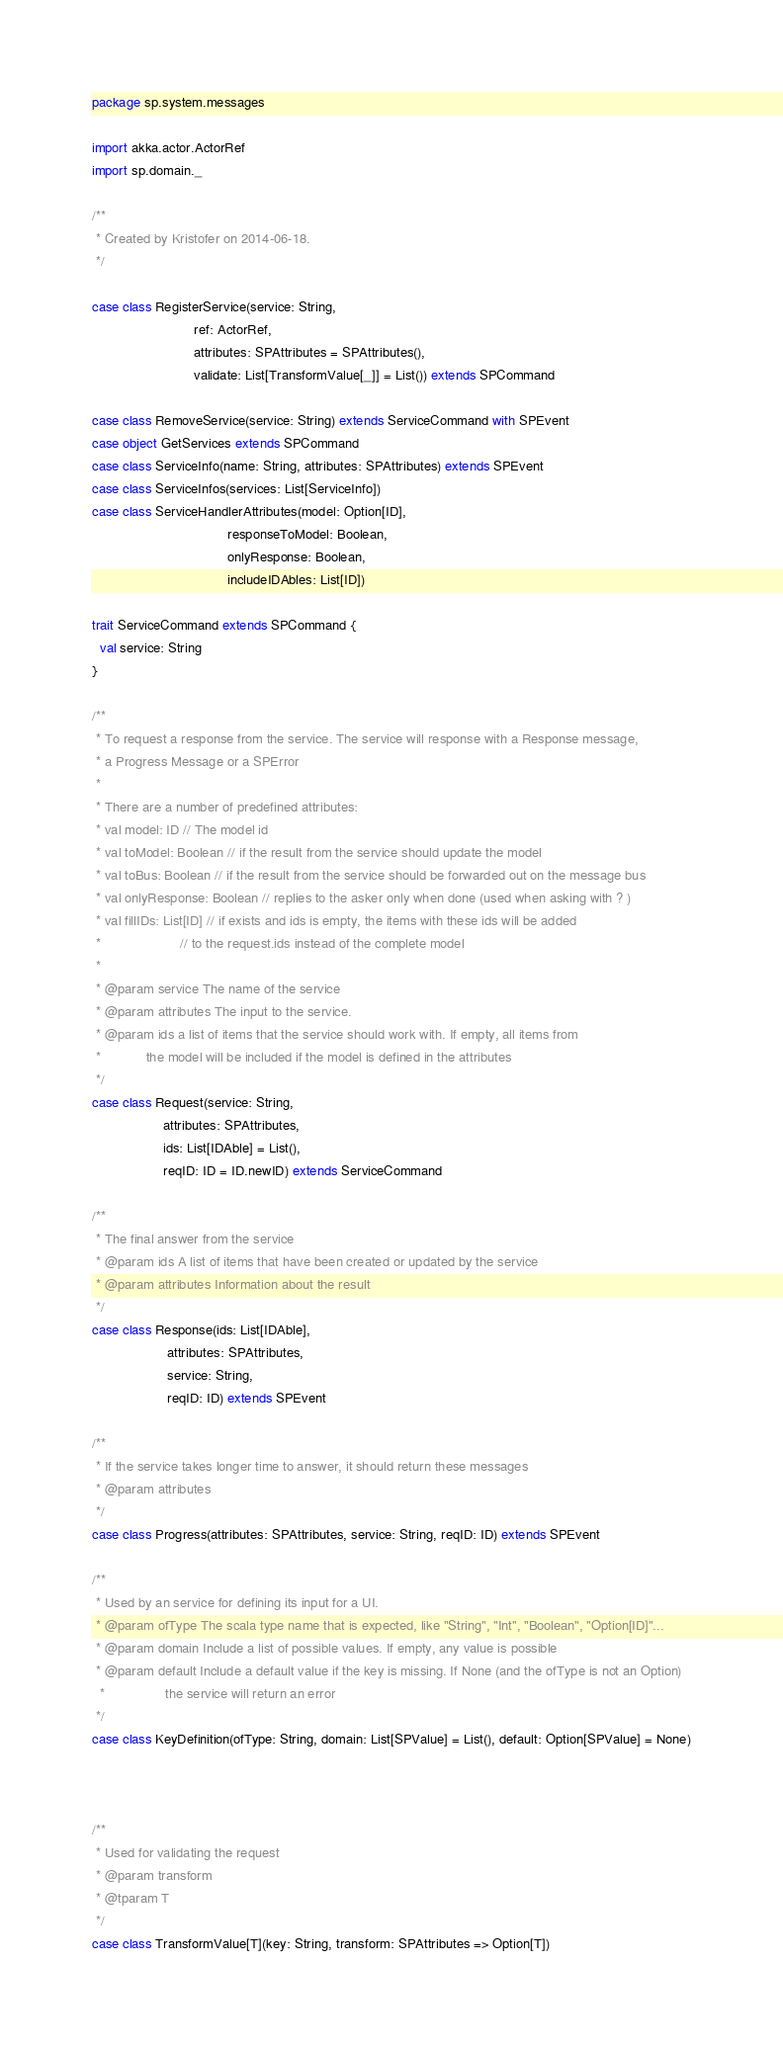<code> <loc_0><loc_0><loc_500><loc_500><_Scala_>package sp.system.messages

import akka.actor.ActorRef
import sp.domain._

/**
 * Created by Kristofer on 2014-06-18.
 */

case class RegisterService(service: String,
                           ref: ActorRef,
                           attributes: SPAttributes = SPAttributes(),
                           validate: List[TransformValue[_]] = List()) extends SPCommand

case class RemoveService(service: String) extends ServiceCommand with SPEvent
case object GetServices extends SPCommand
case class ServiceInfo(name: String, attributes: SPAttributes) extends SPEvent
case class ServiceInfos(services: List[ServiceInfo])
case class ServiceHandlerAttributes(model: Option[ID],
                                    responseToModel: Boolean,
                                    onlyResponse: Boolean,
                                    includeIDAbles: List[ID])

trait ServiceCommand extends SPCommand {
  val service: String
}

/**
 * To request a response from the service. The service will response with a Response message,
 * a Progress Message or a SPError
 *
 * There are a number of predefined attributes:
 * val model: ID // The model id
 * val toModel: Boolean // if the result from the service should update the model
 * val toBus: Boolean // if the result from the service should be forwarded out on the message bus
 * val onlyResponse: Boolean // replies to the asker only when done (used when asking with ? )
 * val fillIDs: List[ID] // if exists and ids is empty, the items with these ids will be added
 *                     // to the request.ids instead of the complete model
 *
 * @param service The name of the service
 * @param attributes The input to the service.
 * @param ids a list of items that the service should work with. If empty, all items from
 *            the model will be included if the model is defined in the attributes
 */
case class Request(service: String,
                   attributes: SPAttributes,
                   ids: List[IDAble] = List(),
                   reqID: ID = ID.newID) extends ServiceCommand

/**
 * The final answer from the service
 * @param ids A list of items that have been created or updated by the service
 * @param attributes Information about the result
 */
case class Response(ids: List[IDAble],
                    attributes: SPAttributes,
                    service: String,
                    reqID: ID) extends SPEvent

/**
 * If the service takes longer time to answer, it should return these messages
 * @param attributes
 */
case class Progress(attributes: SPAttributes, service: String, reqID: ID) extends SPEvent

/**
 * Used by an service for defining its input for a UI.
 * @param ofType The scala type name that is expected, like "String", "Int", "Boolean", "Option[ID]"...
 * @param domain Include a list of possible values. If empty, any value is possible
 * @param default Include a default value if the key is missing. If None (and the ofType is not an Option)
  *                the service will return an error
 */
case class KeyDefinition(ofType: String, domain: List[SPValue] = List(), default: Option[SPValue] = None)



/**
 * Used for validating the request
 * @param transform
 * @tparam T
 */
case class TransformValue[T](key: String, transform: SPAttributes => Option[T])
</code> 